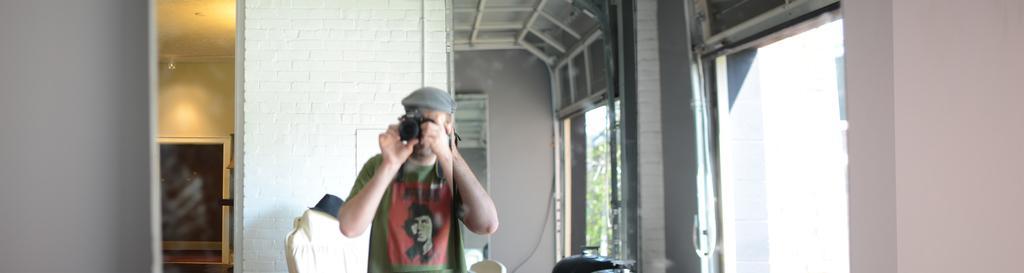Could you give a brief overview of what you see in this image? In this image I can see a person holding a camera. There is a hat, chair, there are walls , windows and there are some other objects. 